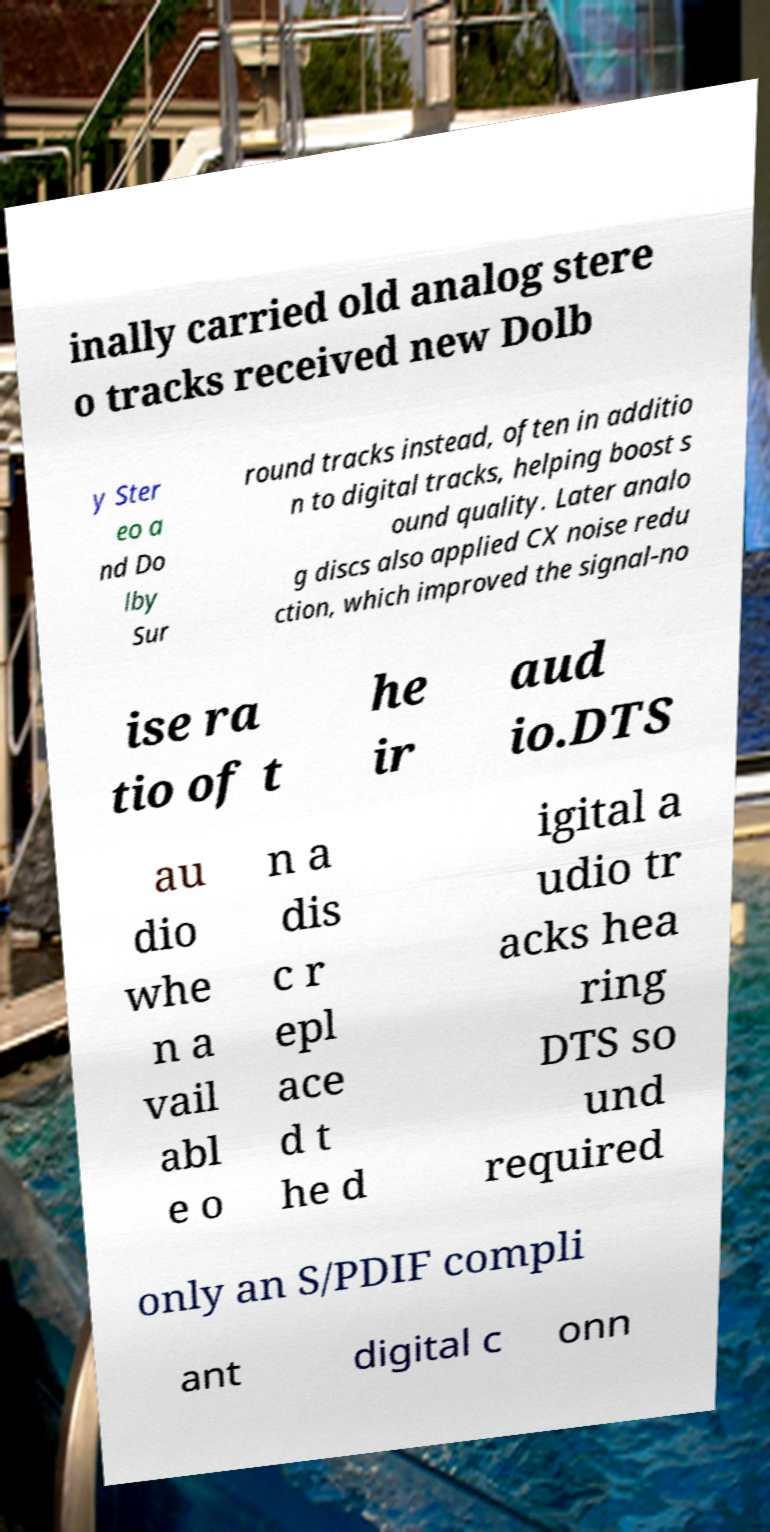What messages or text are displayed in this image? I need them in a readable, typed format. inally carried old analog stere o tracks received new Dolb y Ster eo a nd Do lby Sur round tracks instead, often in additio n to digital tracks, helping boost s ound quality. Later analo g discs also applied CX noise redu ction, which improved the signal-no ise ra tio of t he ir aud io.DTS au dio whe n a vail abl e o n a dis c r epl ace d t he d igital a udio tr acks hea ring DTS so und required only an S/PDIF compli ant digital c onn 